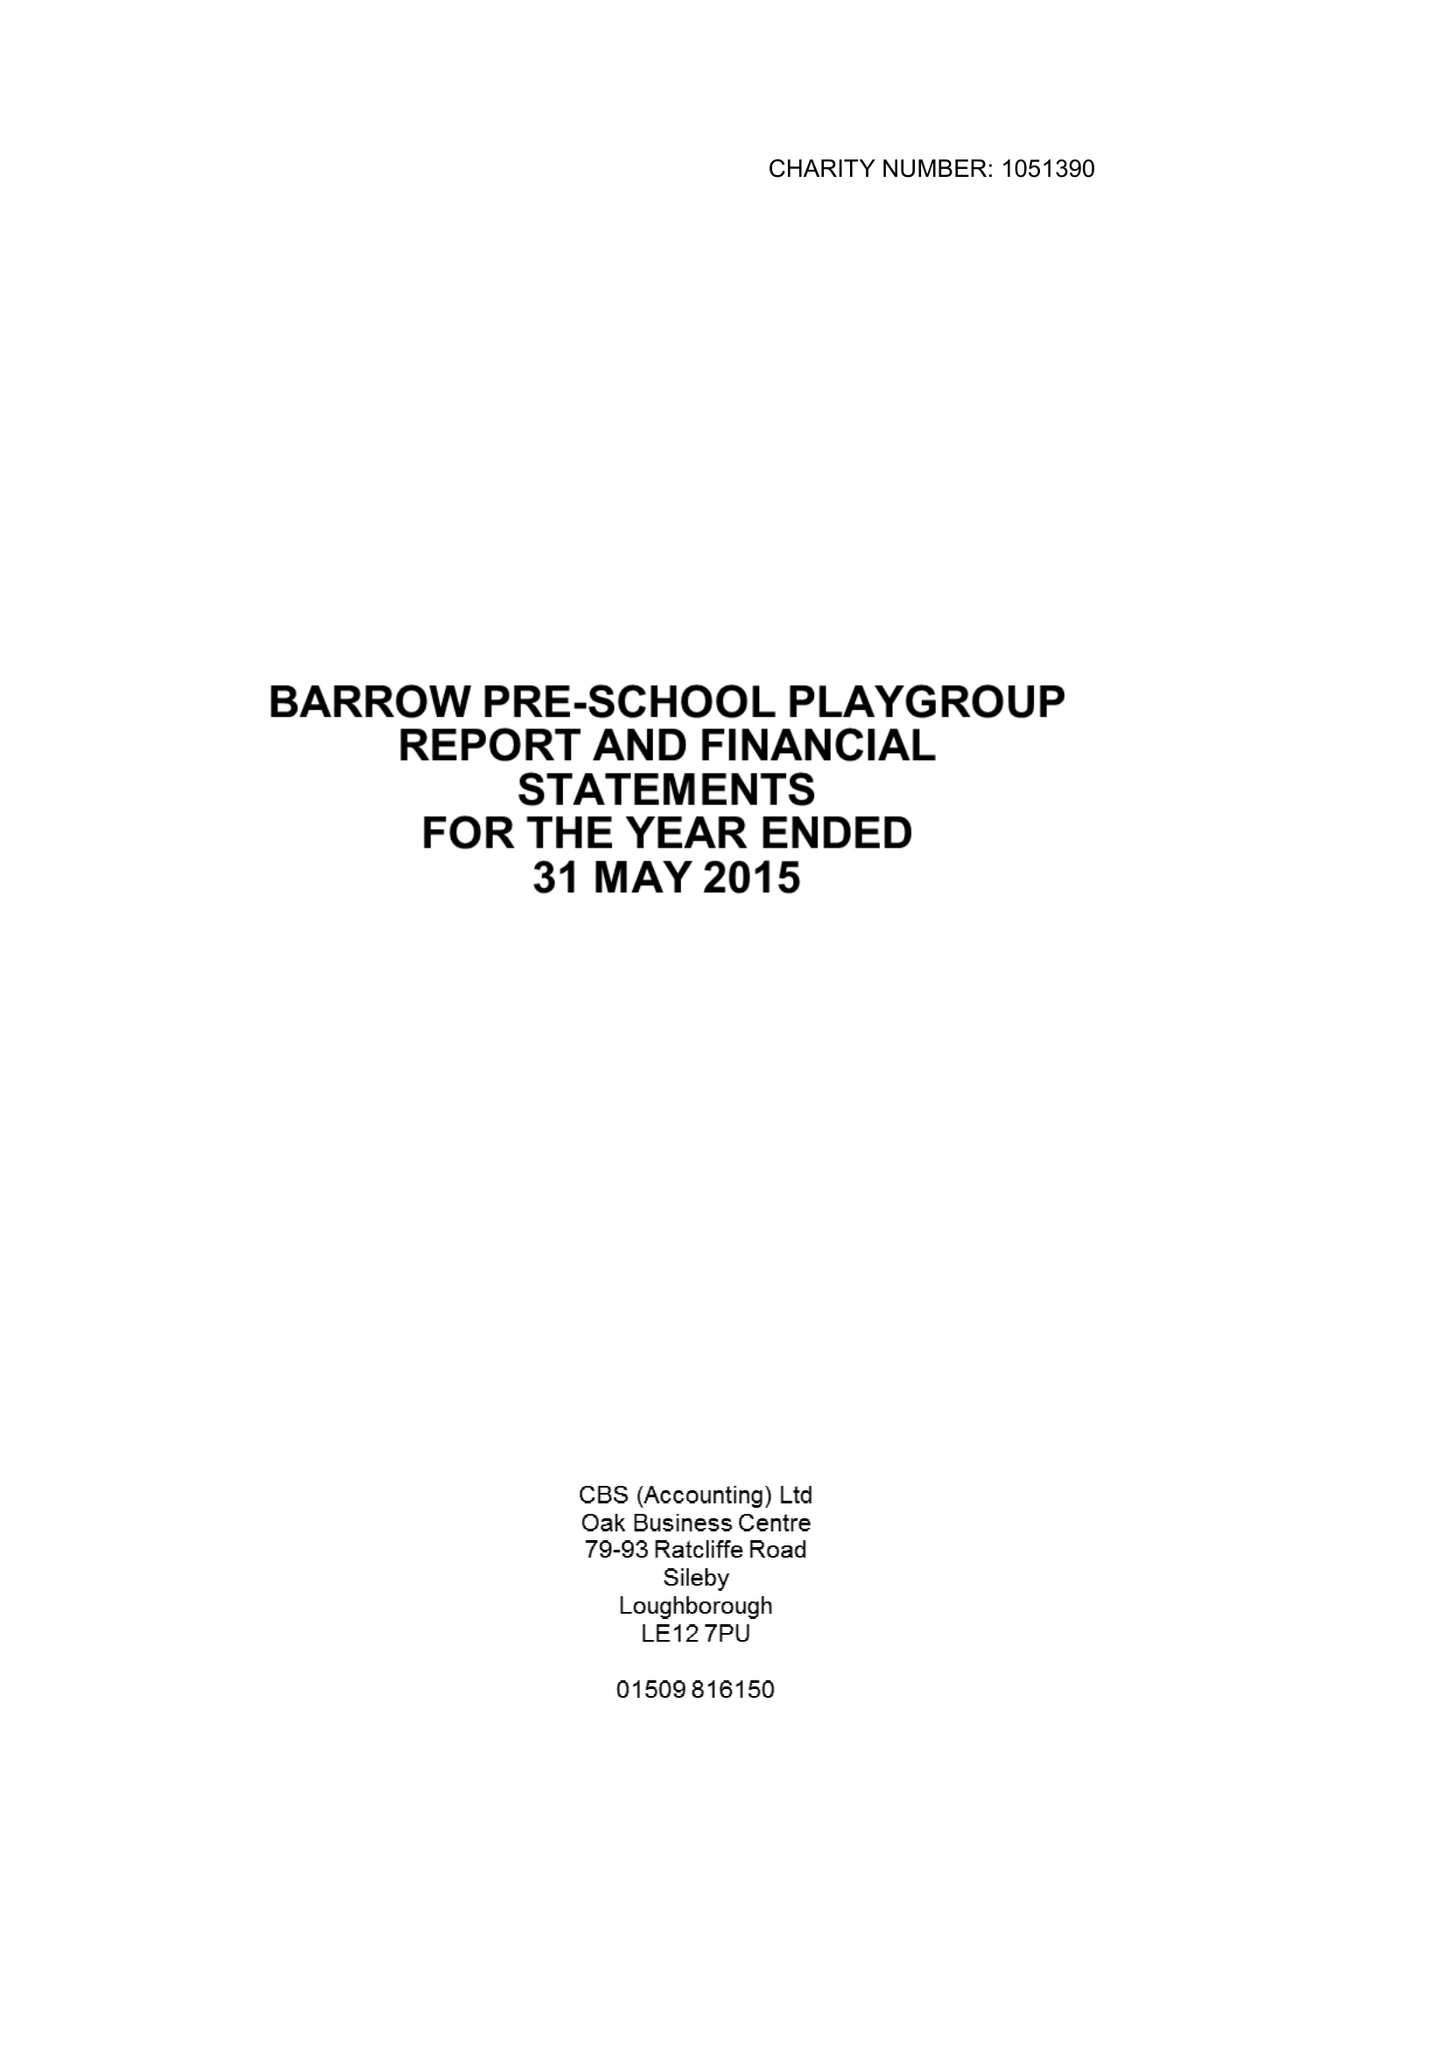What is the value for the address__street_line?
Answer the question using a single word or phrase. 21 WARNER STREET 